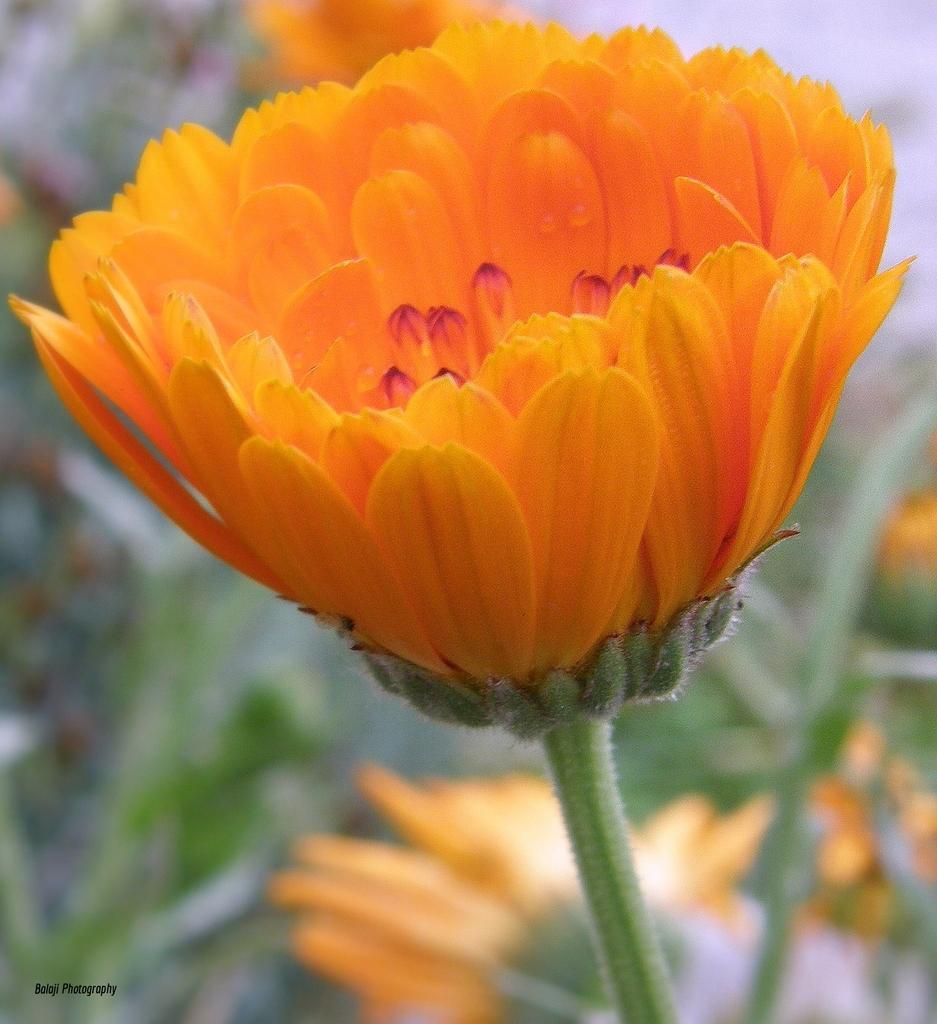Can you describe this image briefly? In this image, we can see plants with flowers and at the bottom, there is some text. 